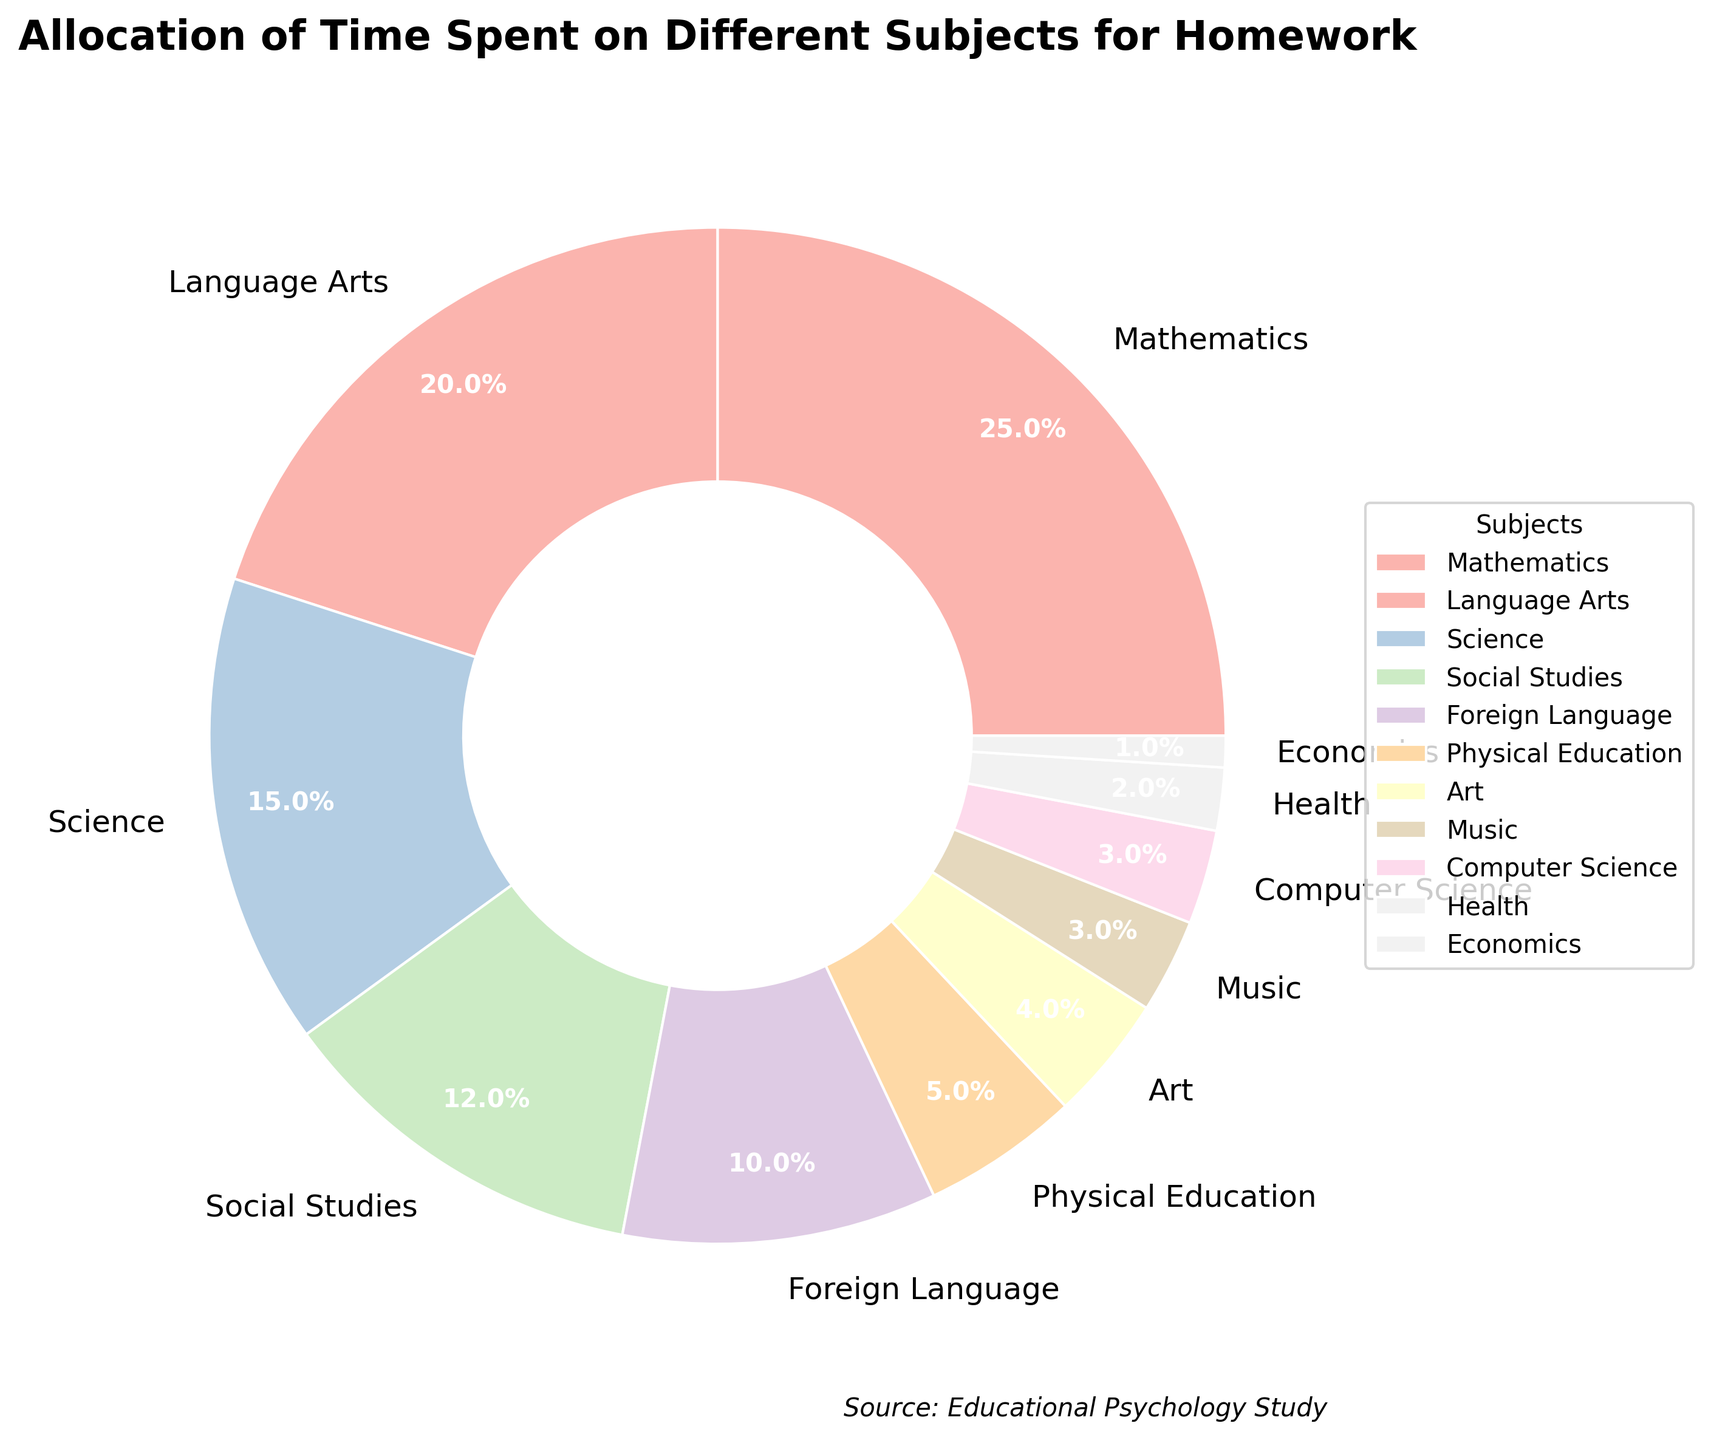What subject has the largest allocation of homework time? According to the pie chart, Mathematics has the largest portion with 25%.
Answer: Mathematics Which subjects occupy less than 5% of the homework time? The pie chart shows that Art, Music, Computer Science, Health, and Economics segments are smaller than 5%.
Answer: Art, Music, Computer Science, Health, Economics Are Mathematics and Science combined greater than 35% of the total? Adding the values for Mathematics (25%) and Science (15%) results in 40%, which is more than 35%.
Answer: Yes Which subject's portion is equal to the combined percentages of Music and Computer Science? Music and Computer Science are both 3%, summing to 6%, which equals the portion for Social Studies.
Answer: Social Studies How much larger is the Language Arts portion compared to Physical Education? Language Arts is 20% and Physical Education is 5%, the difference is 20% - 5% = 15%.
Answer: 15% If the portions for Foreign Language and Health were combined, how would their sum compare to Science? Foreign Language is 10% and Health is 2%, summing to 12%. Science alone is 15%, so Science is larger by 3%.
Answer: Less What subjects make up the top three allocations of homework time? According to the chart, Mathematics (25%), Language Arts (20%), and Science (15%) are the top three.
Answer: Mathematics, Language Arts, Science Which is smaller: the combined allocation for all the artistic subjects (Art and Music) or Computer Science alone? Adding Art (4%) and Music (3%) gives us 7%, while Computer Science alone is 3%. The combined artistic allocation is larger.
Answer: Computer Science alone is smaller 